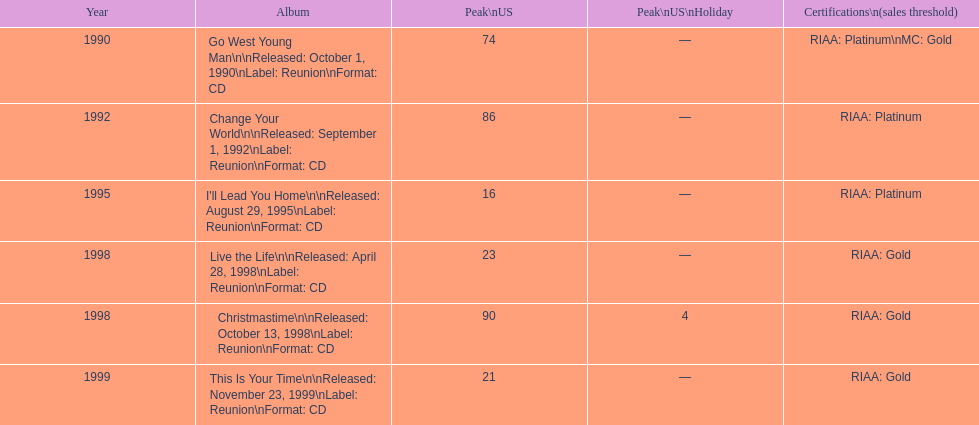Parse the full table. {'header': ['Year', 'Album', 'Peak\\nUS', 'Peak\\nUS\\nHoliday', 'Certifications\\n(sales threshold)'], 'rows': [['1990', 'Go West Young Man\\n\\nReleased: October 1, 1990\\nLabel: Reunion\\nFormat: CD', '74', '—', 'RIAA: Platinum\\nMC: Gold'], ['1992', 'Change Your World\\n\\nReleased: September 1, 1992\\nLabel: Reunion\\nFormat: CD', '86', '—', 'RIAA: Platinum'], ['1995', "I'll Lead You Home\\n\\nReleased: August 29, 1995\\nLabel: Reunion\\nFormat: CD", '16', '—', 'RIAA: Platinum'], ['1998', 'Live the Life\\n\\nReleased: April 28, 1998\\nLabel: Reunion\\nFormat: CD', '23', '—', 'RIAA: Gold'], ['1998', 'Christmastime\\n\\nReleased: October 13, 1998\\nLabel: Reunion\\nFormat: CD', '90', '4', 'RIAA: Gold'], ['1999', 'This Is Your Time\\n\\nReleased: November 23, 1999\\nLabel: Reunion\\nFormat: CD', '21', '—', 'RIAA: Gold']]} What michael w smith album was released before his christmastime album? Live the Life. 